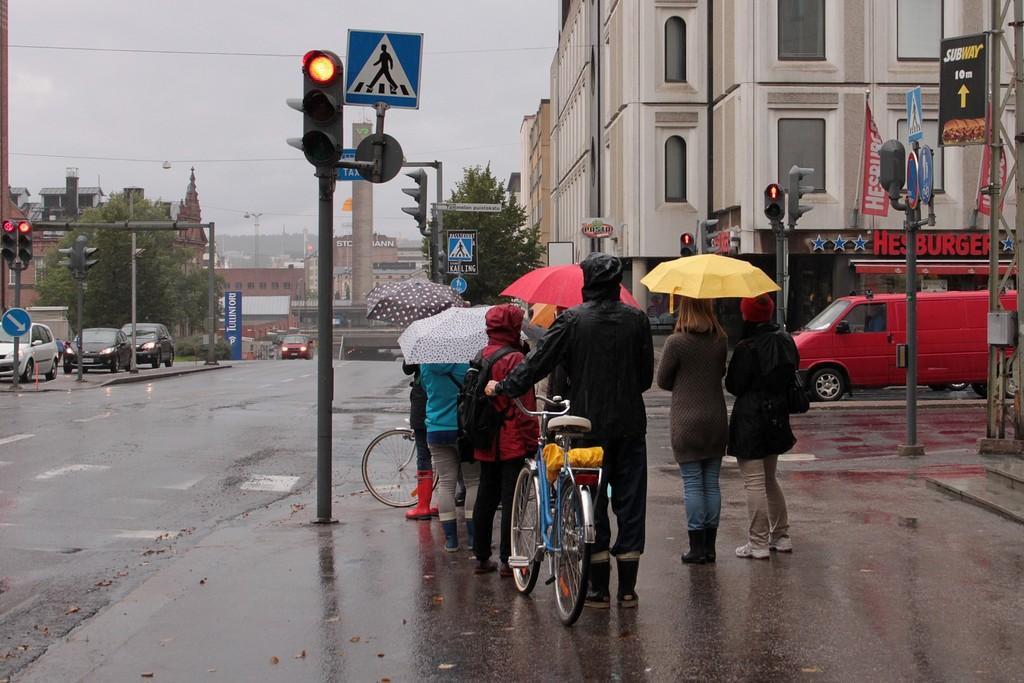Could you give a brief overview of what you see in this image? In this image we can see a few people, among them some are holding the umbrellas, there are some vehicles on the road, also we can see some trees, poles, lights, buildings, wires and boards, in the background we can see the sky. 